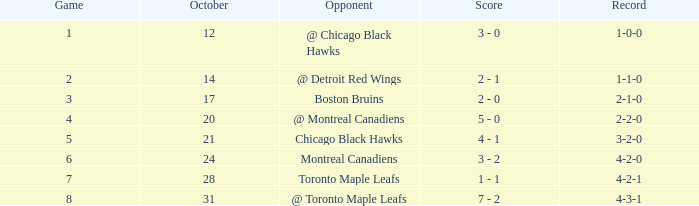What was the game record prior to game 6 against the chicago blackhawks? 3-2-0. 